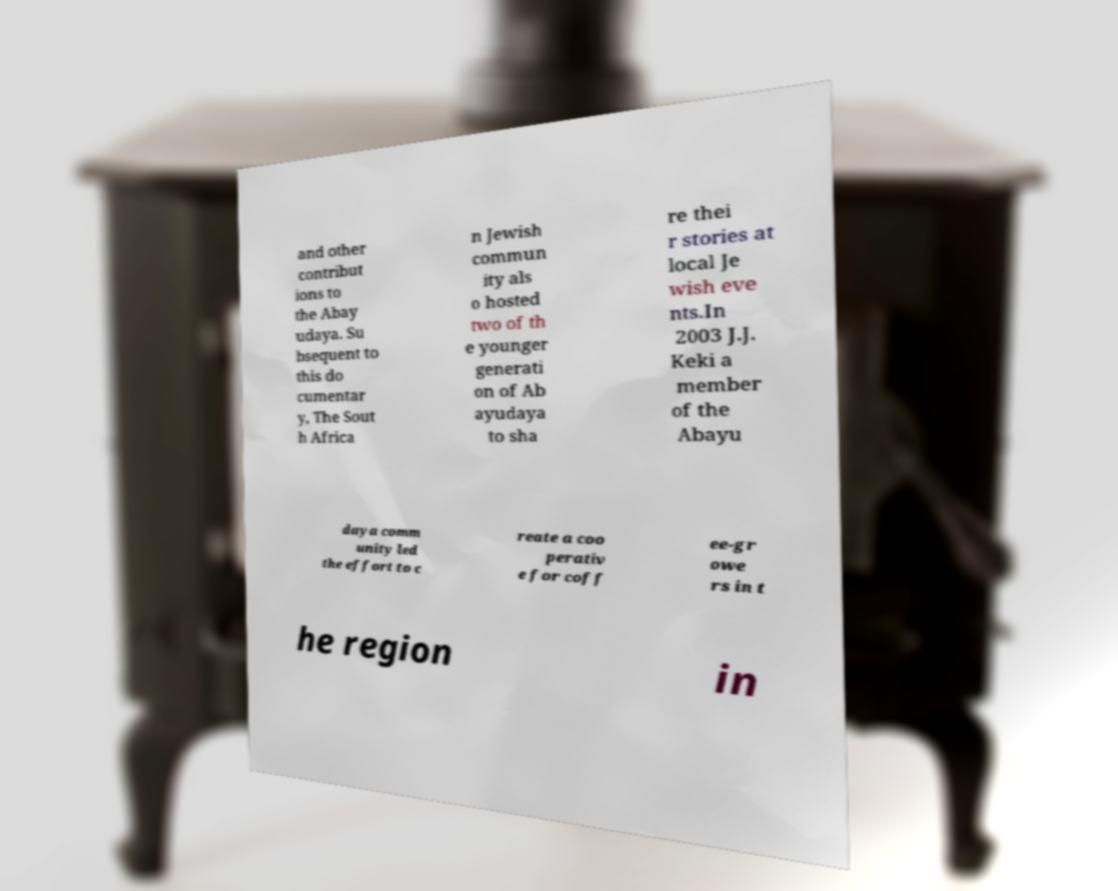Could you extract and type out the text from this image? and other contribut ions to the Abay udaya. Su bsequent to this do cumentar y, The Sout h Africa n Jewish commun ity als o hosted two of th e younger generati on of Ab ayudaya to sha re thei r stories at local Je wish eve nts.In 2003 J.J. Keki a member of the Abayu daya comm unity led the effort to c reate a coo perativ e for coff ee-gr owe rs in t he region in 